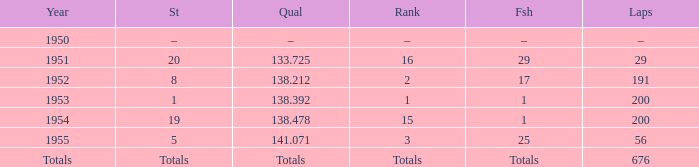What is the start of the race with 676 laps? Totals. 